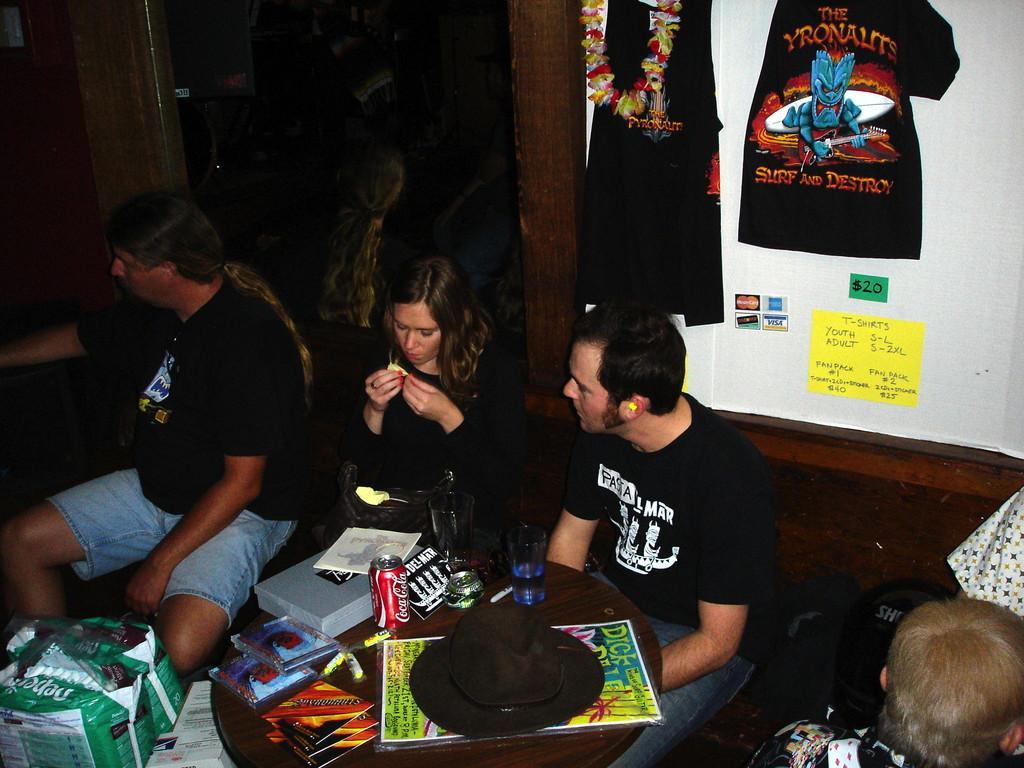Can you describe this image briefly? In this image I can see few people are sitting and I can see all of them are wearing black dress. Here I can see a table and on it I can see I can few glasses, a black hat and few other stuffs. In background I can see few black colour dresses and here on this yellow colour paper I can see something is written. 